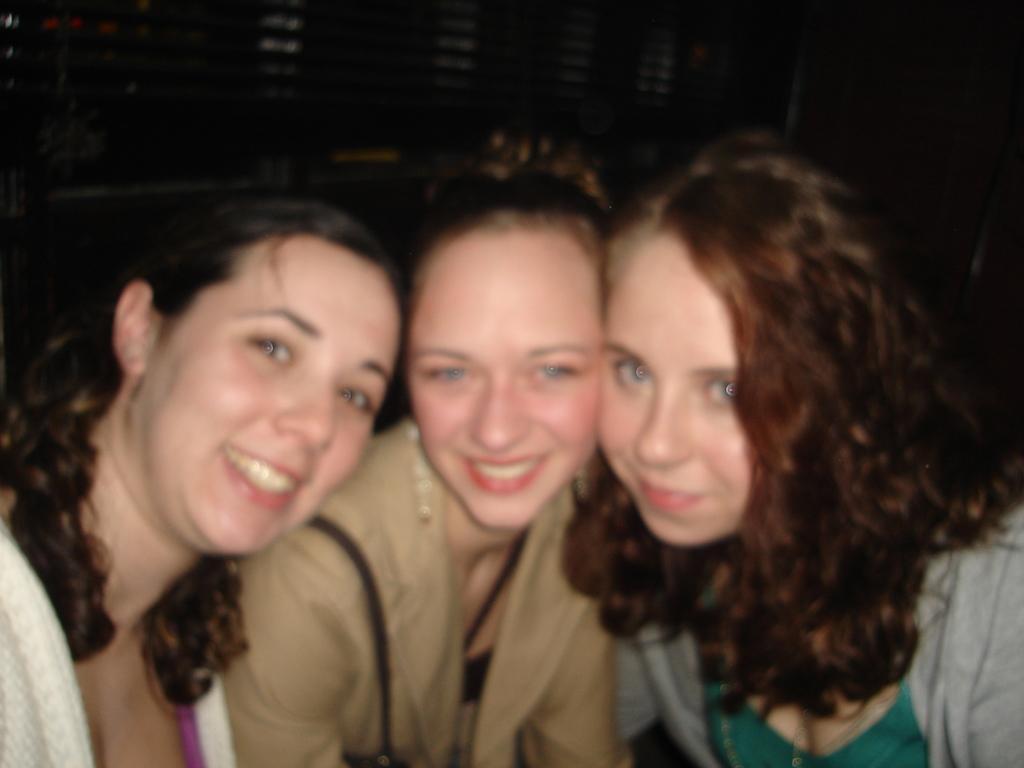Describe this image in one or two sentences. In this picture there is a woman who is wearing brown dress. Beside her there is another woman who is wearing grey t-shirt. On the left we can see another woman who is wearing white t-shirt. Everyone is smiling. At the top we can see the darkness. 